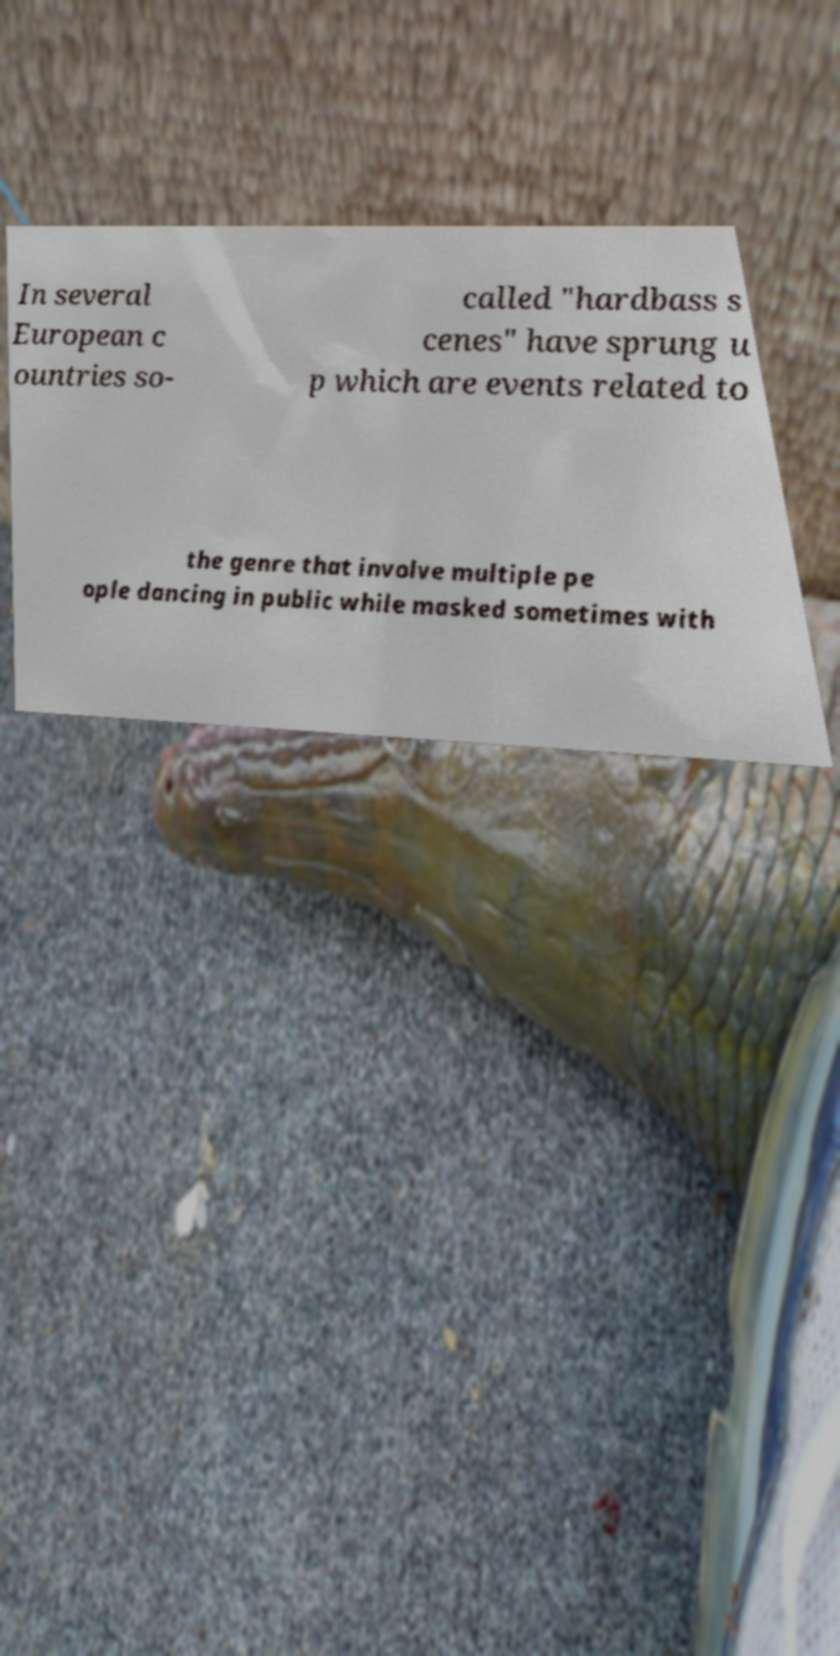There's text embedded in this image that I need extracted. Can you transcribe it verbatim? In several European c ountries so- called "hardbass s cenes" have sprung u p which are events related to the genre that involve multiple pe ople dancing in public while masked sometimes with 